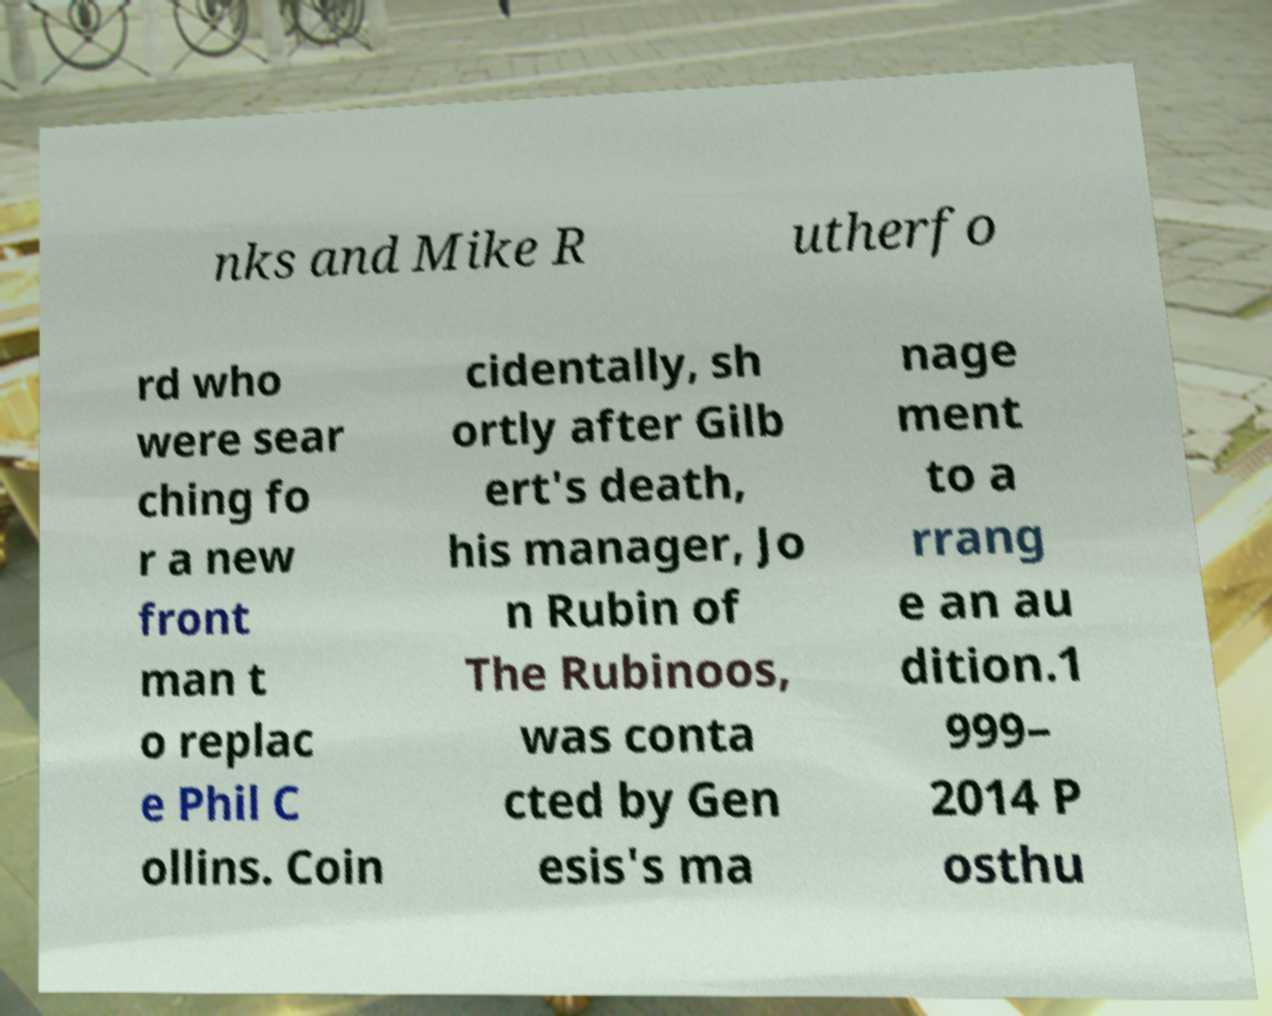Could you extract and type out the text from this image? nks and Mike R utherfo rd who were sear ching fo r a new front man t o replac e Phil C ollins. Coin cidentally, sh ortly after Gilb ert's death, his manager, Jo n Rubin of The Rubinoos, was conta cted by Gen esis's ma nage ment to a rrang e an au dition.1 999– 2014 P osthu 